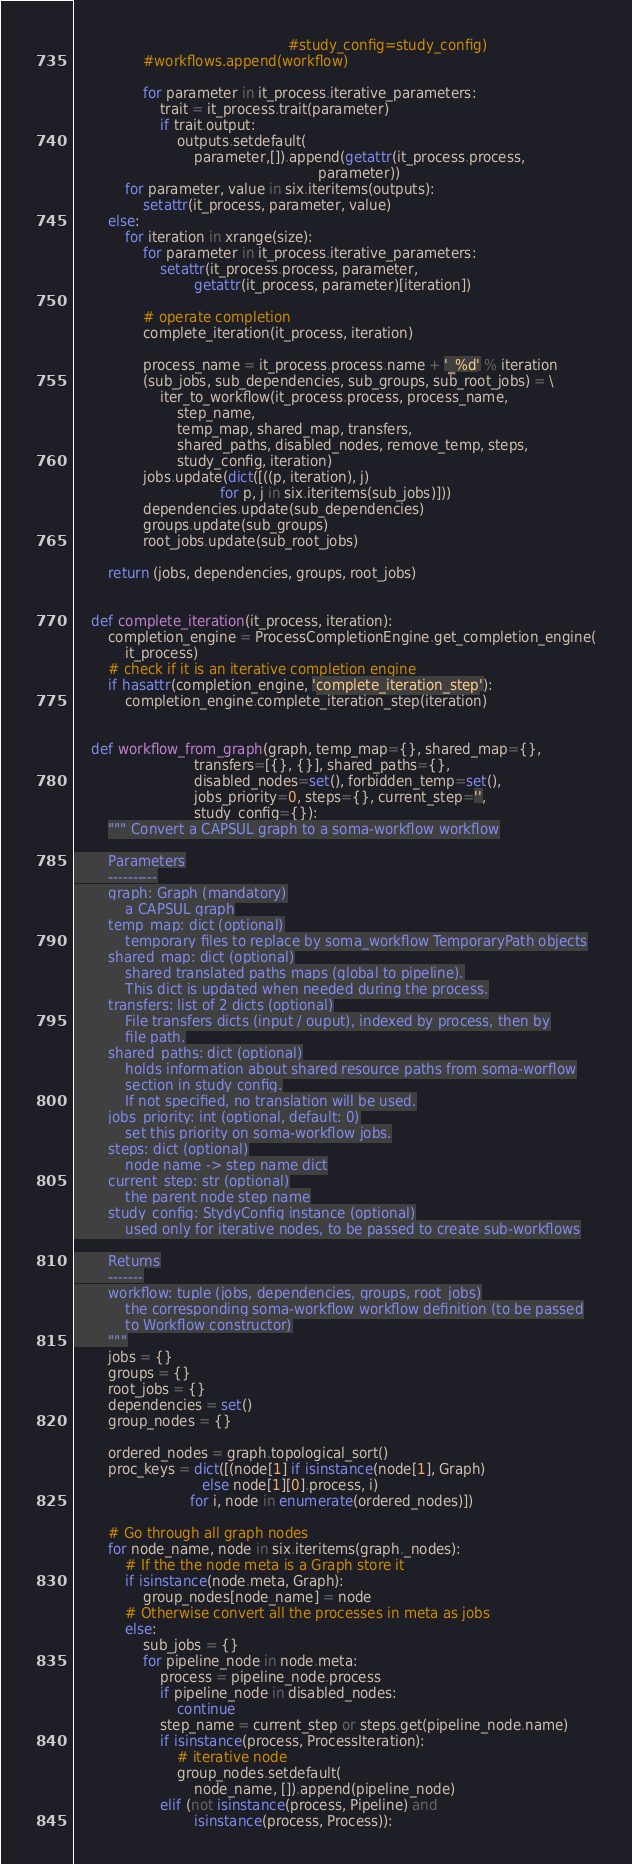<code> <loc_0><loc_0><loc_500><loc_500><_Python_>                                                  #study_config=study_config)
                #workflows.append(workflow)

                for parameter in it_process.iterative_parameters:
                    trait = it_process.trait(parameter)
                    if trait.output:
                        outputs.setdefault(
                            parameter,[]).append(getattr(it_process.process,
                                                         parameter))
            for parameter, value in six.iteritems(outputs):
                setattr(it_process, parameter, value)
        else:
            for iteration in xrange(size):
                for parameter in it_process.iterative_parameters:
                    setattr(it_process.process, parameter,
                            getattr(it_process, parameter)[iteration])

                # operate completion
                complete_iteration(it_process, iteration)

                process_name = it_process.process.name + '_%d' % iteration
                (sub_jobs, sub_dependencies, sub_groups, sub_root_jobs) = \
                    iter_to_workflow(it_process.process, process_name,
                        step_name,
                        temp_map, shared_map, transfers,
                        shared_paths, disabled_nodes, remove_temp, steps,
                        study_config, iteration)
                jobs.update(dict([((p, iteration), j)
                                  for p, j in six.iteritems(sub_jobs)]))
                dependencies.update(sub_dependencies)
                groups.update(sub_groups)
                root_jobs.update(sub_root_jobs)

        return (jobs, dependencies, groups, root_jobs)


    def complete_iteration(it_process, iteration):
        completion_engine = ProcessCompletionEngine.get_completion_engine(
            it_process)
        # check if it is an iterative completion engine
        if hasattr(completion_engine, 'complete_iteration_step'):
            completion_engine.complete_iteration_step(iteration)


    def workflow_from_graph(graph, temp_map={}, shared_map={},
                            transfers=[{}, {}], shared_paths={},
                            disabled_nodes=set(), forbidden_temp=set(),
                            jobs_priority=0, steps={}, current_step='',
                            study_config={}):
        """ Convert a CAPSUL graph to a soma-workflow workflow

        Parameters
        ----------
        graph: Graph (mandatory)
            a CAPSUL graph
        temp_map: dict (optional)
            temporary files to replace by soma_workflow TemporaryPath objects
        shared_map: dict (optional)
            shared translated paths maps (global to pipeline).
            This dict is updated when needed during the process.
        transfers: list of 2 dicts (optional)
            File transfers dicts (input / ouput), indexed by process, then by
            file path.
        shared_paths: dict (optional)
            holds information about shared resource paths from soma-worflow
            section in study config.
            If not specified, no translation will be used.
        jobs_priority: int (optional, default: 0)
            set this priority on soma-workflow jobs.
        steps: dict (optional)
            node name -> step name dict
        current_step: str (optional)
            the parent node step name
        study_config: StydyConfig instance (optional)
            used only for iterative nodes, to be passed to create sub-workflows

        Returns
        -------
        workflow: tuple (jobs, dependencies, groups, root_jobs)
            the corresponding soma-workflow workflow definition (to be passed
            to Workflow constructor)
        """
        jobs = {}
        groups = {}
        root_jobs = {}
        dependencies = set()
        group_nodes = {}

        ordered_nodes = graph.topological_sort()
        proc_keys = dict([(node[1] if isinstance(node[1], Graph)
                              else node[1][0].process, i)
                           for i, node in enumerate(ordered_nodes)])

        # Go through all graph nodes
        for node_name, node in six.iteritems(graph._nodes):
            # If the the node meta is a Graph store it
            if isinstance(node.meta, Graph):
                group_nodes[node_name] = node
            # Otherwise convert all the processes in meta as jobs
            else:
                sub_jobs = {}
                for pipeline_node in node.meta:
                    process = pipeline_node.process
                    if pipeline_node in disabled_nodes:
                        continue
                    step_name = current_step or steps.get(pipeline_node.name)
                    if isinstance(process, ProcessIteration):
                        # iterative node
                        group_nodes.setdefault(
                            node_name, []).append(pipeline_node)
                    elif (not isinstance(process, Pipeline) and
                            isinstance(process, Process)):</code> 